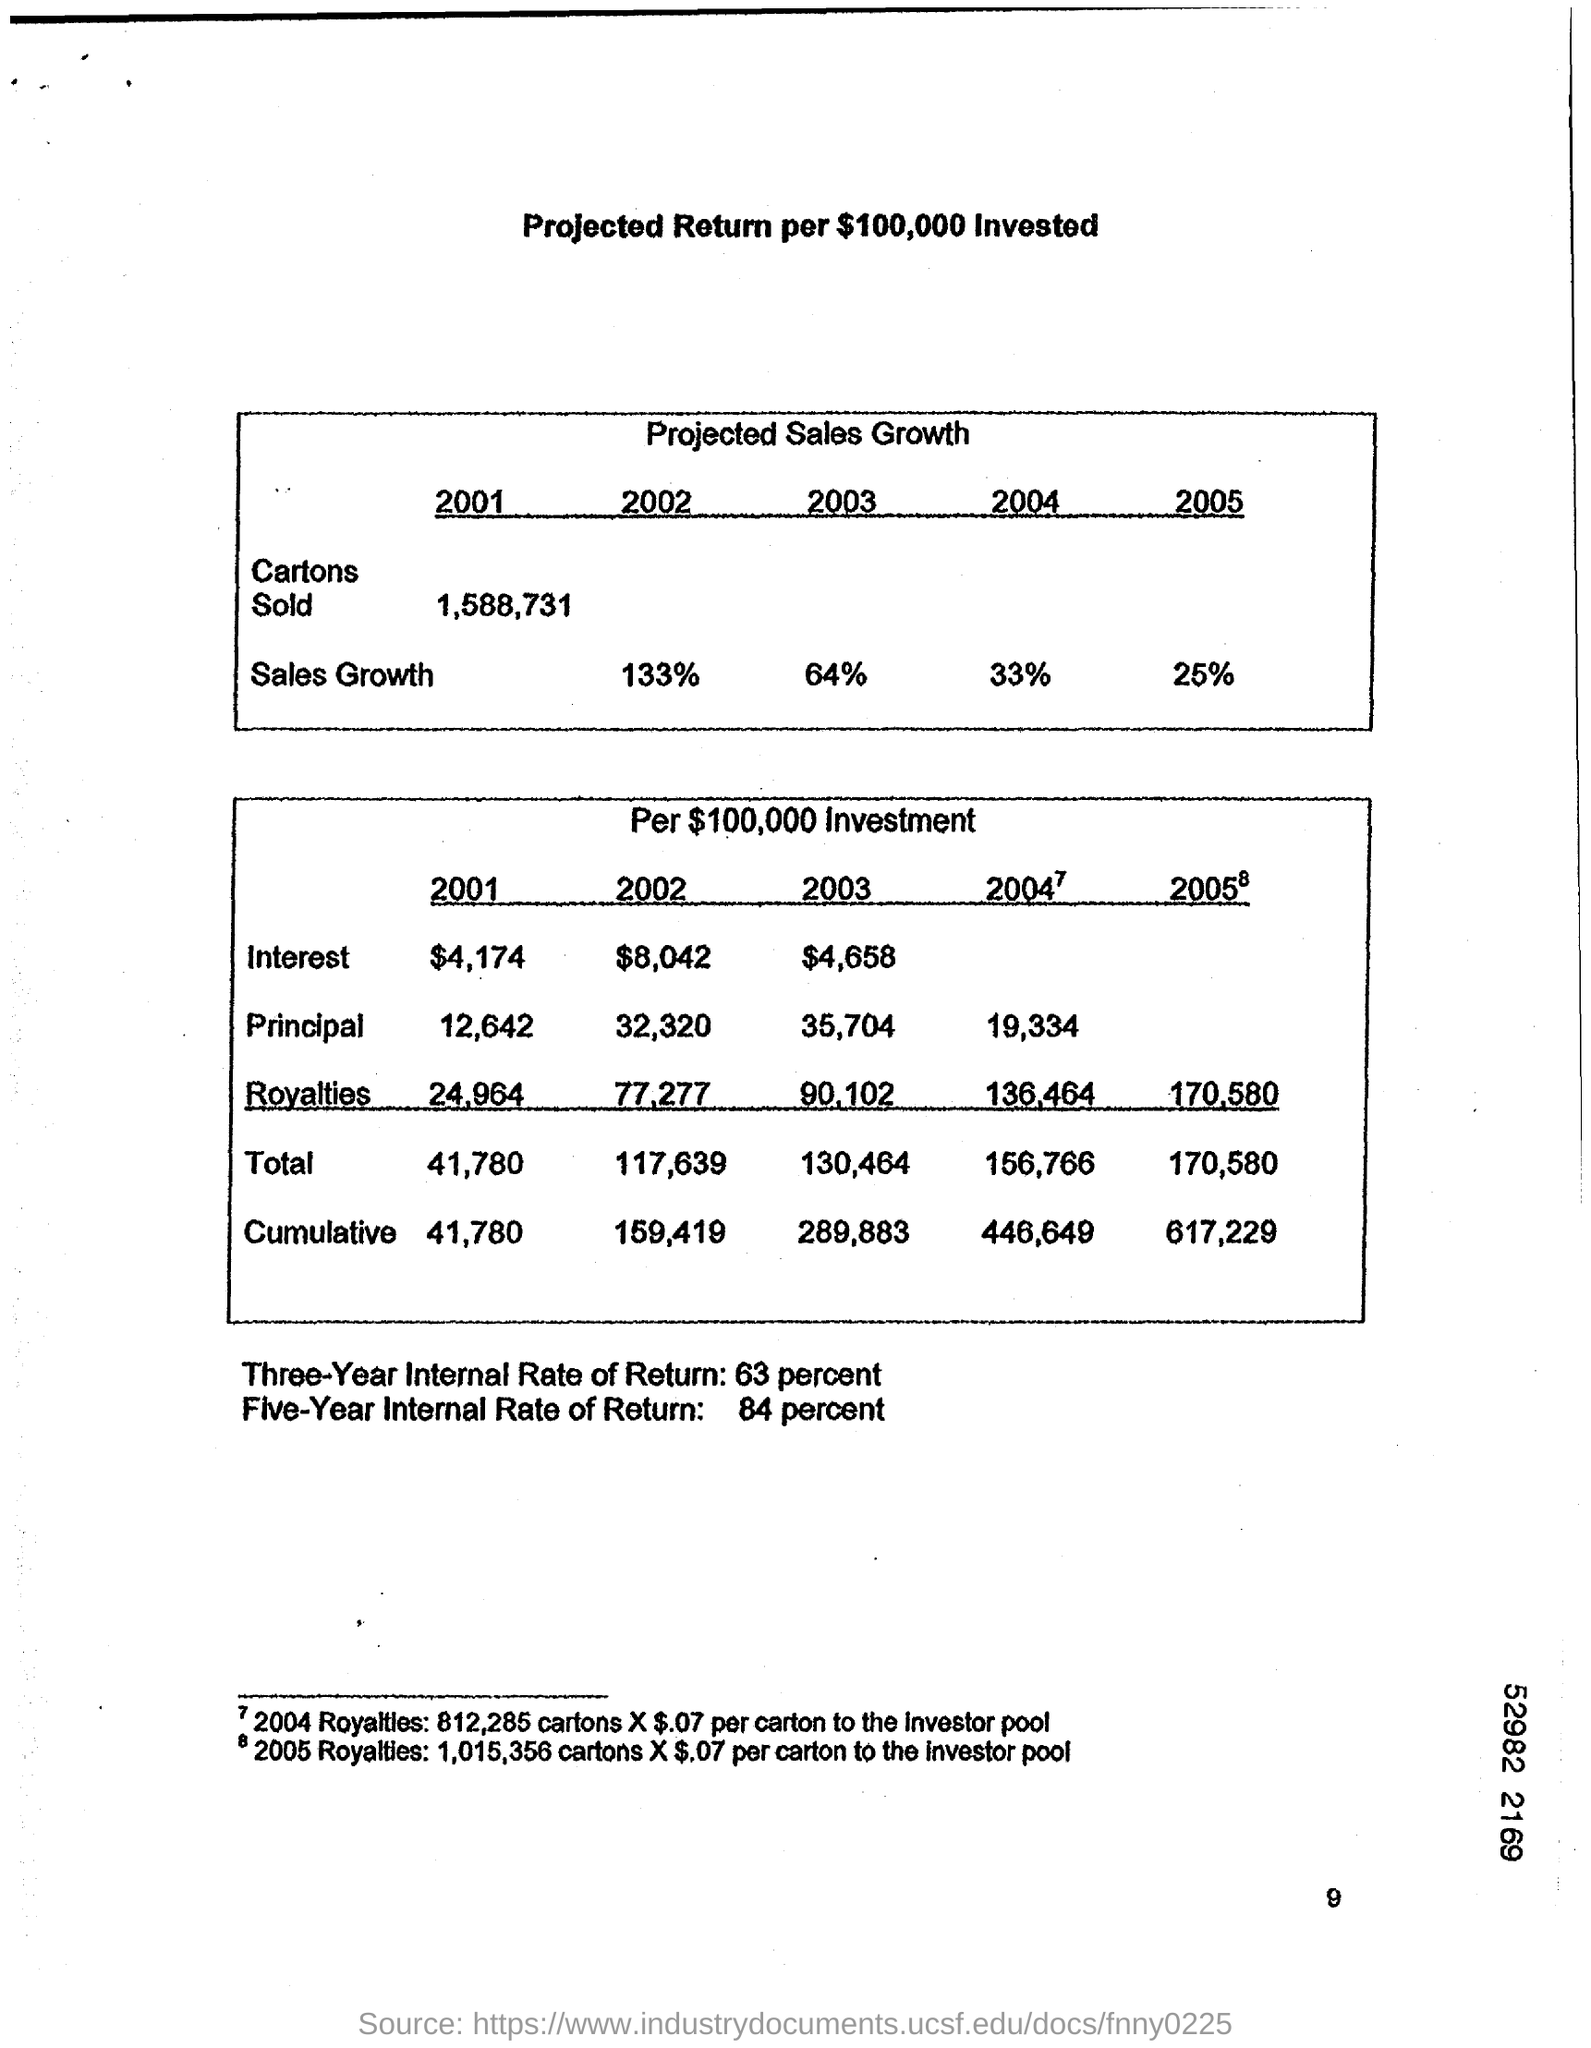Give some essential details in this illustration. The three-year internal rate of return is 63 percent. The Five-Year Internal Rate of Return is 84 percent. 